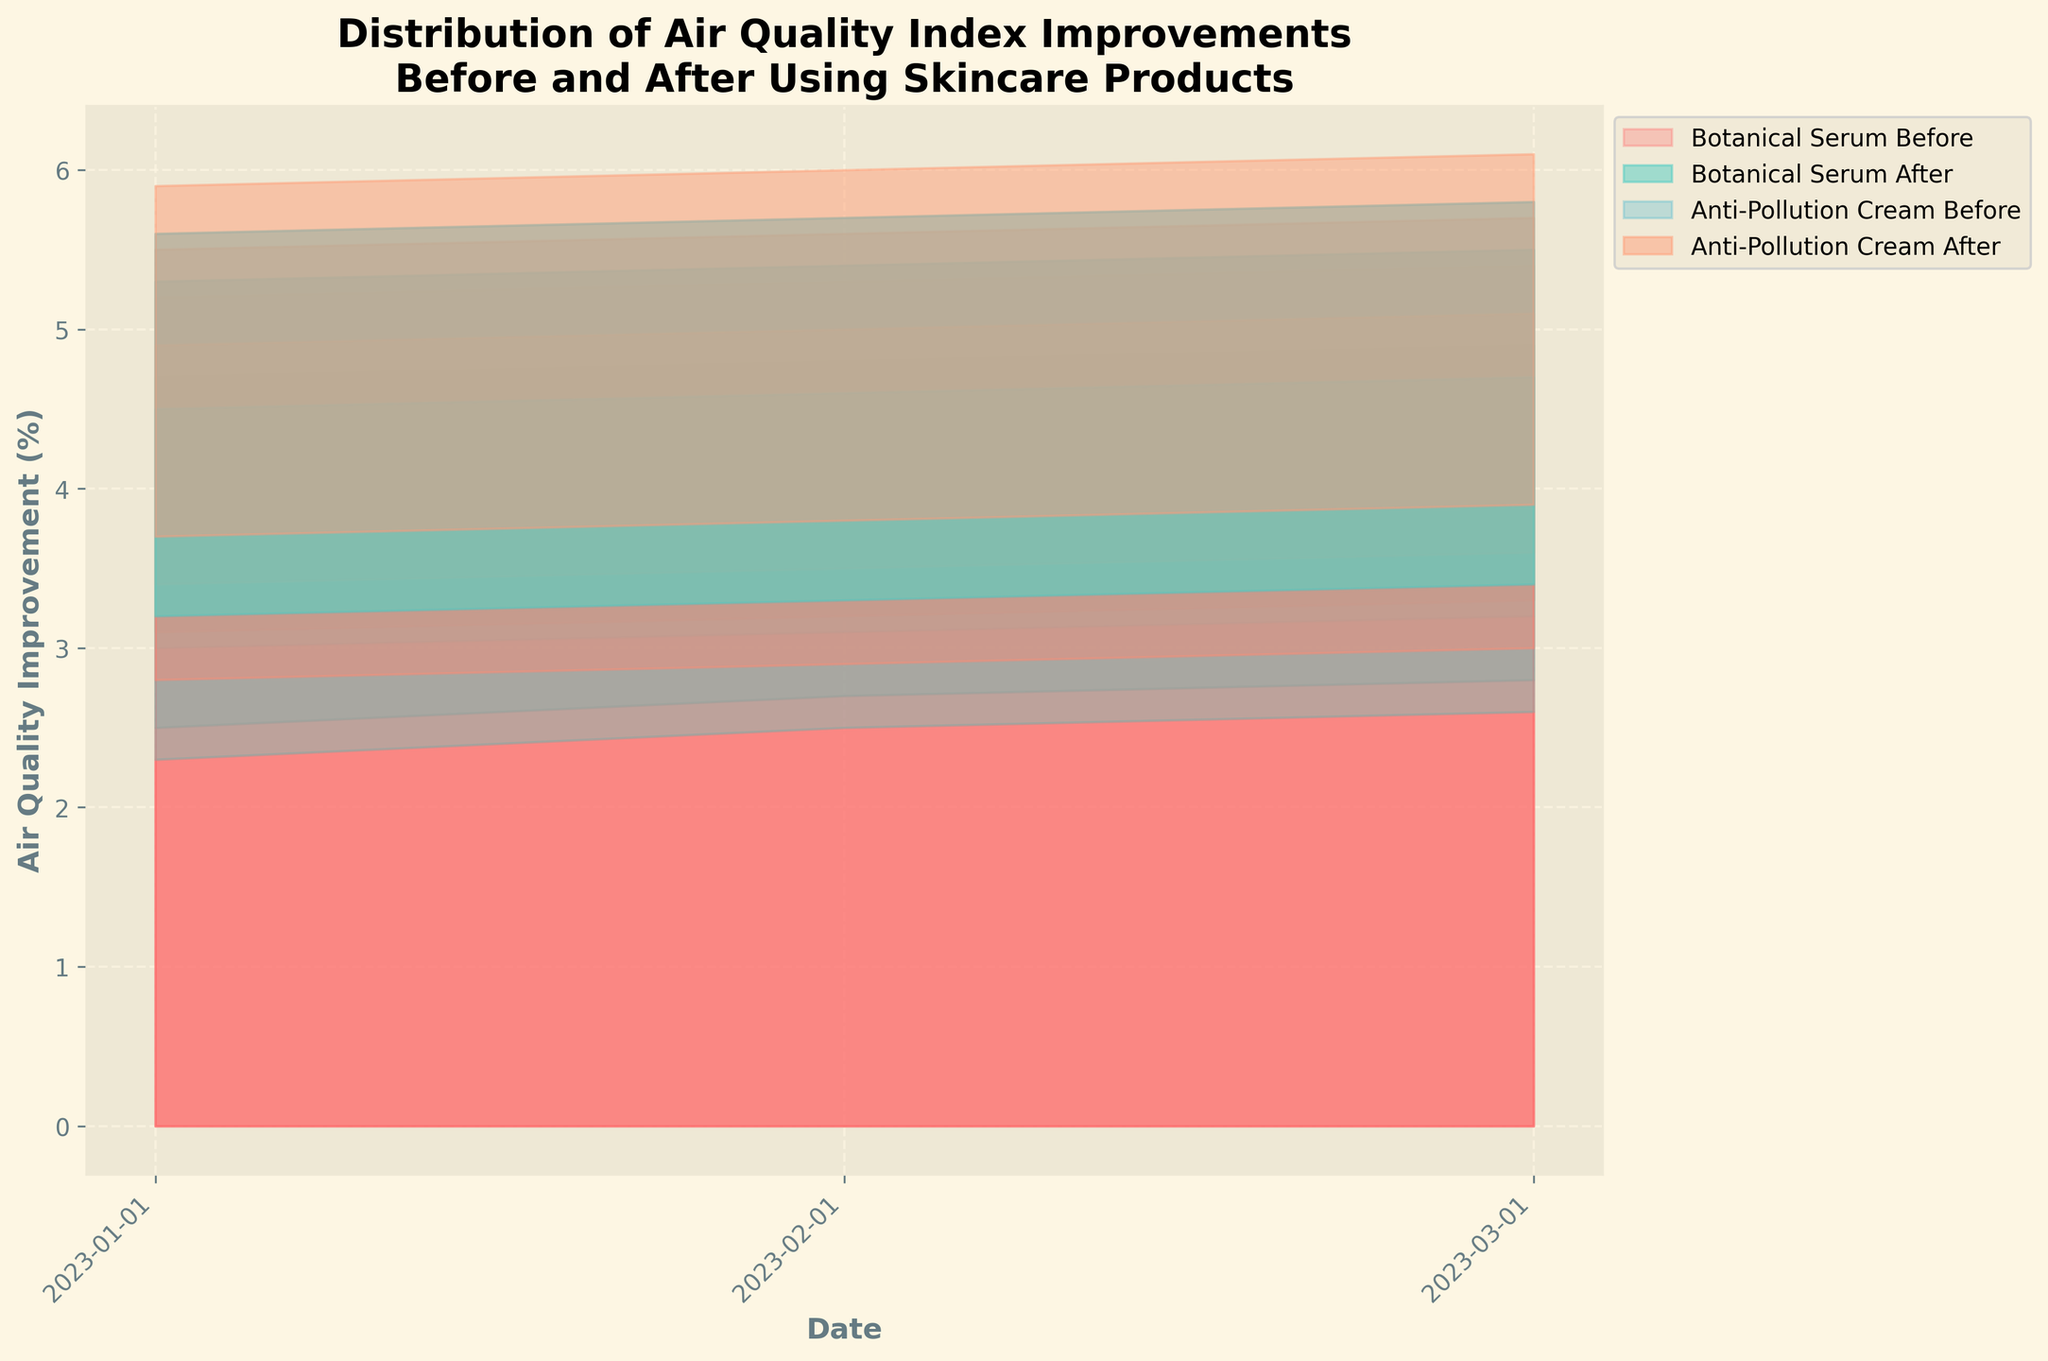What is the title of the figure? The title is usually found at the top of the figure. For this figure, it should clearly describe what the data and visualization are about.
Answer: Distribution of Air Quality Index Improvements Before and After Using Skincare Products What does the x-axis represent? The x-axis typically represents the variable that is being measured at different intervals. In this case, it shows the dates on which the air quality improvements were measured.
Answer: Date How many locations are represented in the figure? Count the unique locations listed in the dataset. Each location should have a series on the chart.
Answer: Four (New York, London, Los Angeles, Paris) What color represents 'Botanical Serum Before'? Colors are used to differentiate different data series in the chart. According to the fill_between parameters, the color for 'Botanical Serum Before' is the first color in the 'colors' array.
Answer: Red How does the air quality improvement after using 'Anti-Pollution Cream' in Paris on March 2023 compare to that in New York? Find the respective locations and dates in the dataset and compare their 'Air Quality Improvement After - Anti-Pollution Cream (%)' values.
Answer: Higher in Paris (6.1%) compared to New York (5.4%) Which product shows a higher improvement in air quality after use in Los Angeles on February 2023? Compare the 'Air Quality Improvement After' values for both products in Los Angeles on February 2023.
Answer: Anti-Pollution Cream (5.0%) What is the overall trend in air quality improvement for 'Botanical Serum Before' over the three months? Look at the 'Air Quality Improvement Before - Botanical Serum (%)' values for all the locations across the months to identify if the values are increasing or decreasing.
Answer: Increasing By how much did the 'Botanical Serum' improve the air quality in London from January to March 2023? Subtract the value in January 2023 from the value in March 2023 for 'Botanical Serum' in London.
Answer: 0.2% What percentage improvement does the 'Anti-Pollution Cream' show in both New York and Los Angeles in January 2023? Look at the 'Air Quality Improvement Before' and 'After' values for 'Anti-Pollution Cream' in New York and Los Angeles and compare them.
Answer: New York: 5.2%, Los Angeles: 4.9% Which city shows the highest air quality improvement with 'Botanical Serum After' in March 2023? Compare the 'Air Quality Improvement After - Botanical Serum (%)' values for March 2023 across all cities.
Answer: Paris (5.8%) 